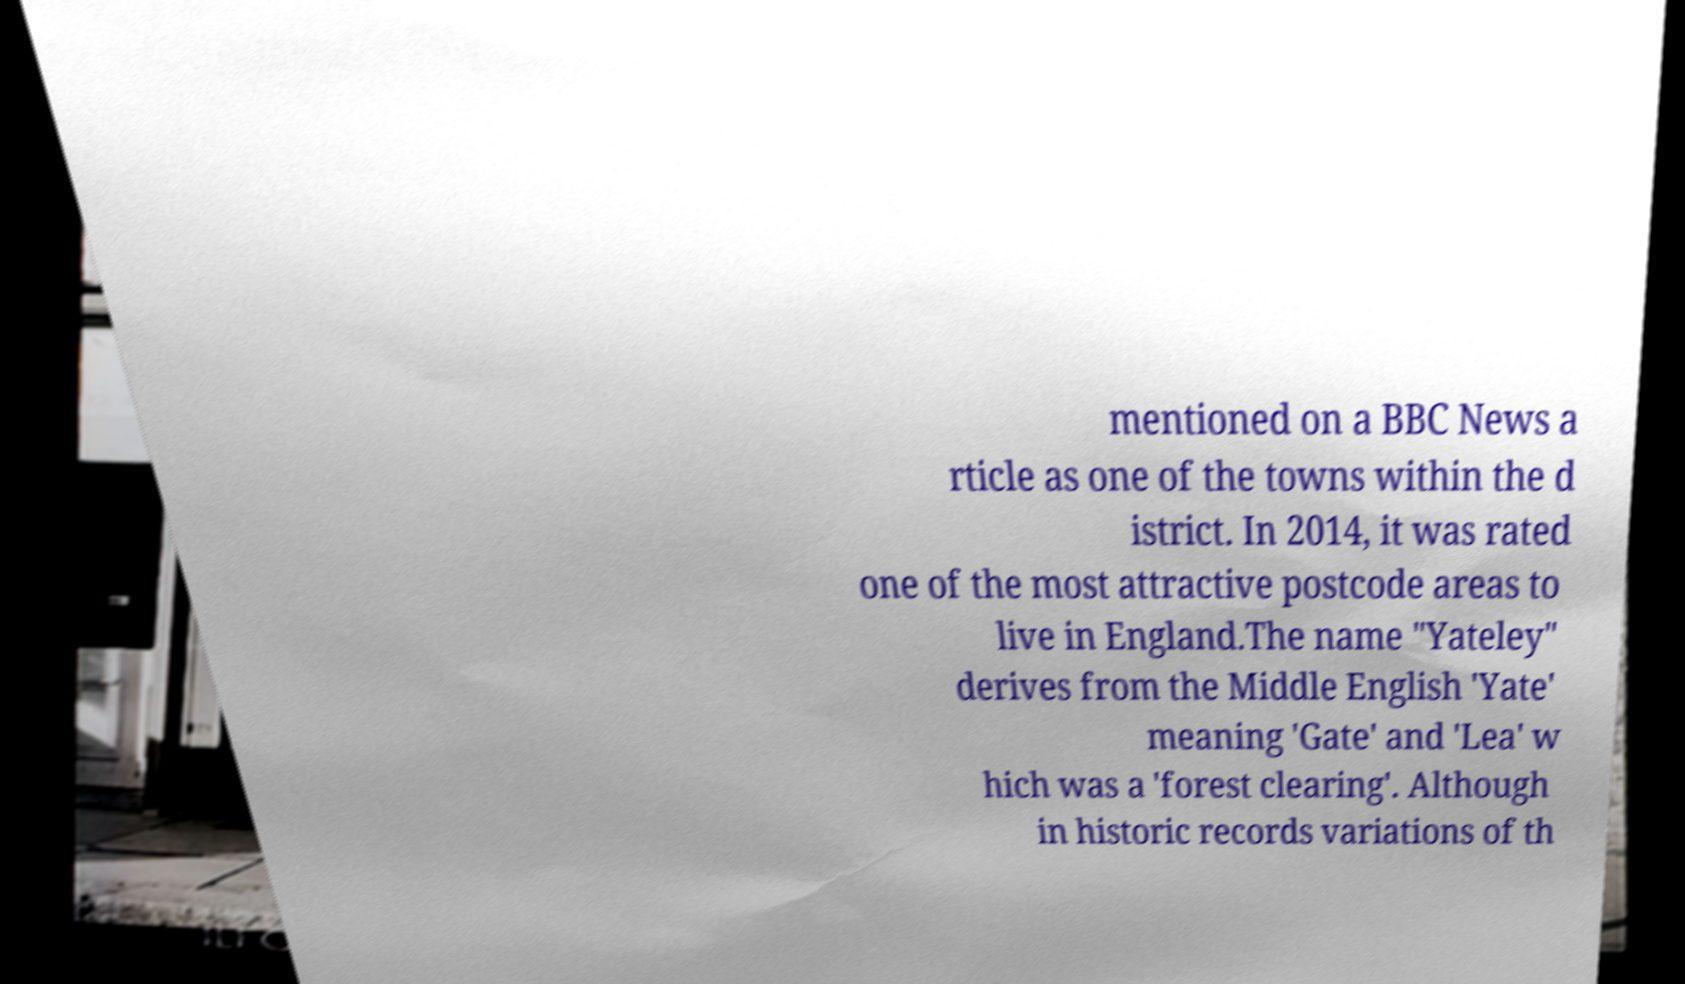Please read and relay the text visible in this image. What does it say? mentioned on a BBC News a rticle as one of the towns within the d istrict. In 2014, it was rated one of the most attractive postcode areas to live in England.The name "Yateley" derives from the Middle English 'Yate' meaning 'Gate' and 'Lea' w hich was a 'forest clearing'. Although in historic records variations of th 